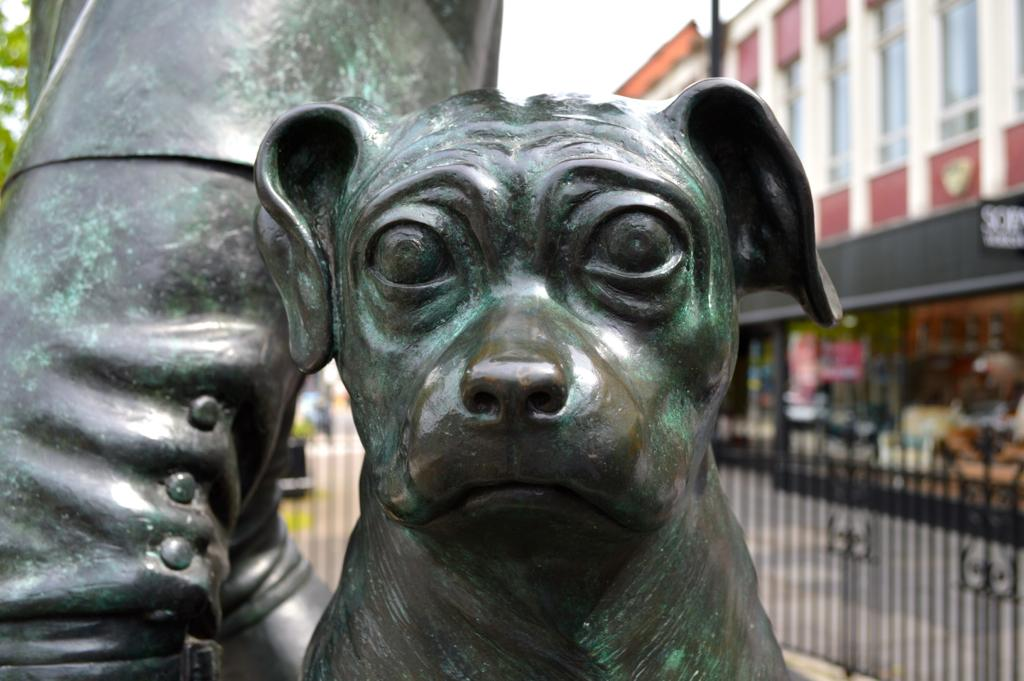What is the main subject of the image? There is a statue of a dog in the image. What can be seen on the right side of the image? There are buildings and a fencing on the right side of the image. What is at the bottom of the image? There is a road at the bottom of the image. What type of vegetation is on the left side of the image? There is a tree on the left side of the image. What type of bead is used to decorate the dog statue in the image? There is no mention of beads or any decorative elements on the dog statue in the image. 